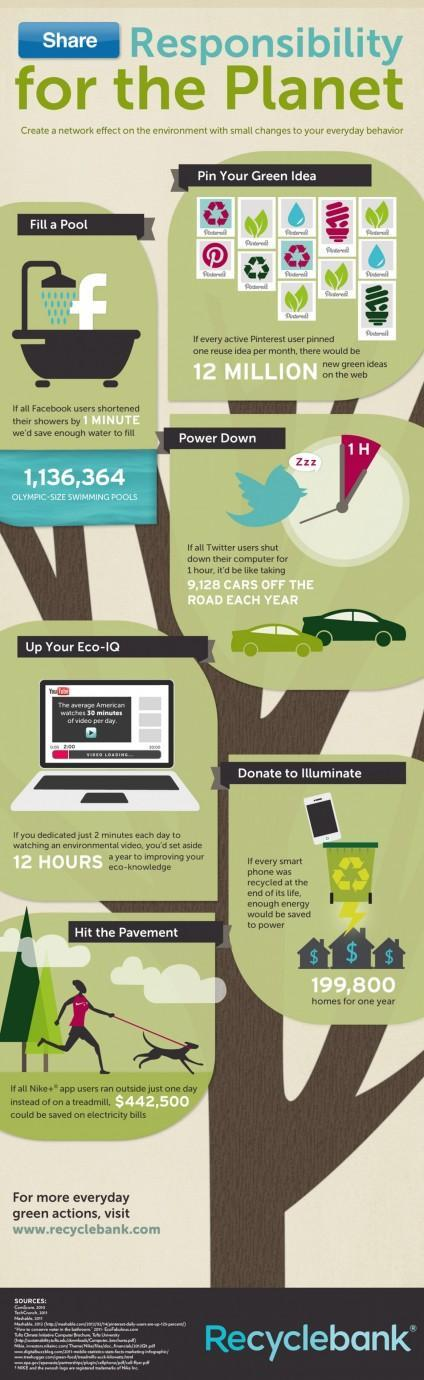If you spent two minutes watching an environmental video each day, how long would you have spend in a year?
Answer the question with a short phrase. 12 hours How much would you save on electricity bills, if all Nike app users did not use the treadmill for one day ($)? 442,500 How many cars are shown in the image? 2 How many Olympic size swimming pools could be filled if all facebook users shortened their showers by 1 minute? 1,136,364 How many reuse ideas would there be on the web, if every pinterest user pinned a single reuse Idea/month? 12 million How many houses can be illuminated each year, by recycling all the smartphones? 199,800 Out of the six  "small changes"  mentioned here, which are the last two? Donate to illuminate, hit the pavement How many small changes that have a major impact on the environment, are mentioned? 6 For how many minutes should Twitter users power down their computers, to eliminate 9128 cars from the roads? 60 